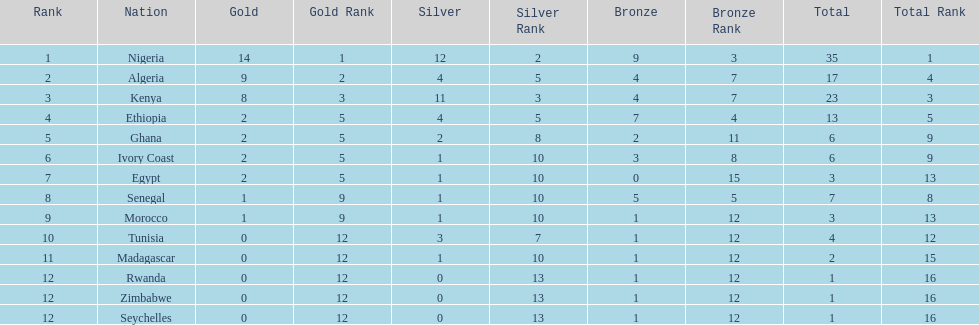How long is the list of countries that won any medals? 14. 